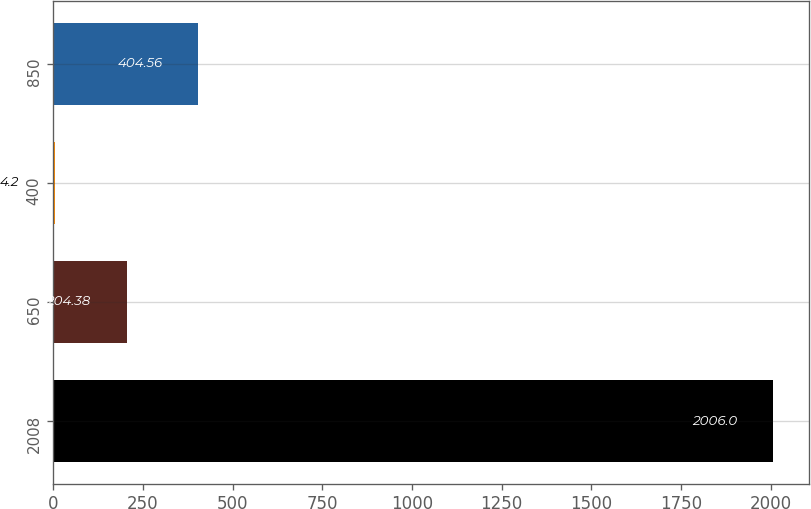Convert chart to OTSL. <chart><loc_0><loc_0><loc_500><loc_500><bar_chart><fcel>2008<fcel>650<fcel>400<fcel>850<nl><fcel>2006<fcel>204.38<fcel>4.2<fcel>404.56<nl></chart> 